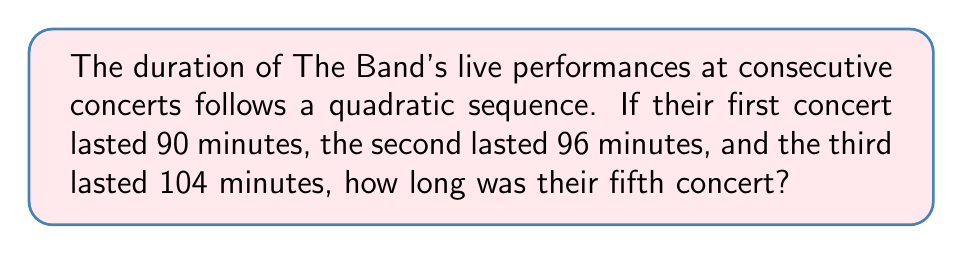Could you help me with this problem? Let's approach this step-by-step:

1) In a quadratic sequence, the nth term is given by $an^2 + bn + c$, where $a$, $b$, and $c$ are constants.

2) We have three known terms:
   1st term (n=1): 90 minutes
   2nd term (n=2): 96 minutes
   3rd term (n=3): 104 minutes

3) Let's set up three equations:
   $a(1)^2 + b(1) + c = 90$
   $a(2)^2 + b(2) + c = 96$
   $a(3)^2 + b(3) + c = 104$

4) Simplify:
   $a + b + c = 90$ ... (1)
   $4a + 2b + c = 96$ ... (2)
   $9a + 3b + c = 104$ ... (3)

5) Subtract (1) from (2):
   $3a + b = 6$ ... (4)

6) Subtract (2) from (3):
   $5a + b = 8$ ... (5)

7) Subtract (4) from (5):
   $2a = 2$
   $a = 1$

8) Substitute $a = 1$ in (4):
   $3(1) + b = 6$
   $b = 3$

9) Substitute $a = 1$ and $b = 3$ in (1):
   $1 + 3 + c = 90$
   $c = 86$

10) Therefore, the quadratic sequence is given by:
    $n^2 + 3n + 86$

11) For the 5th concert (n=5):
    $5^2 + 3(5) + 86 = 25 + 15 + 86 = 126$

Thus, the fifth concert lasted 126 minutes.
Answer: 126 minutes 